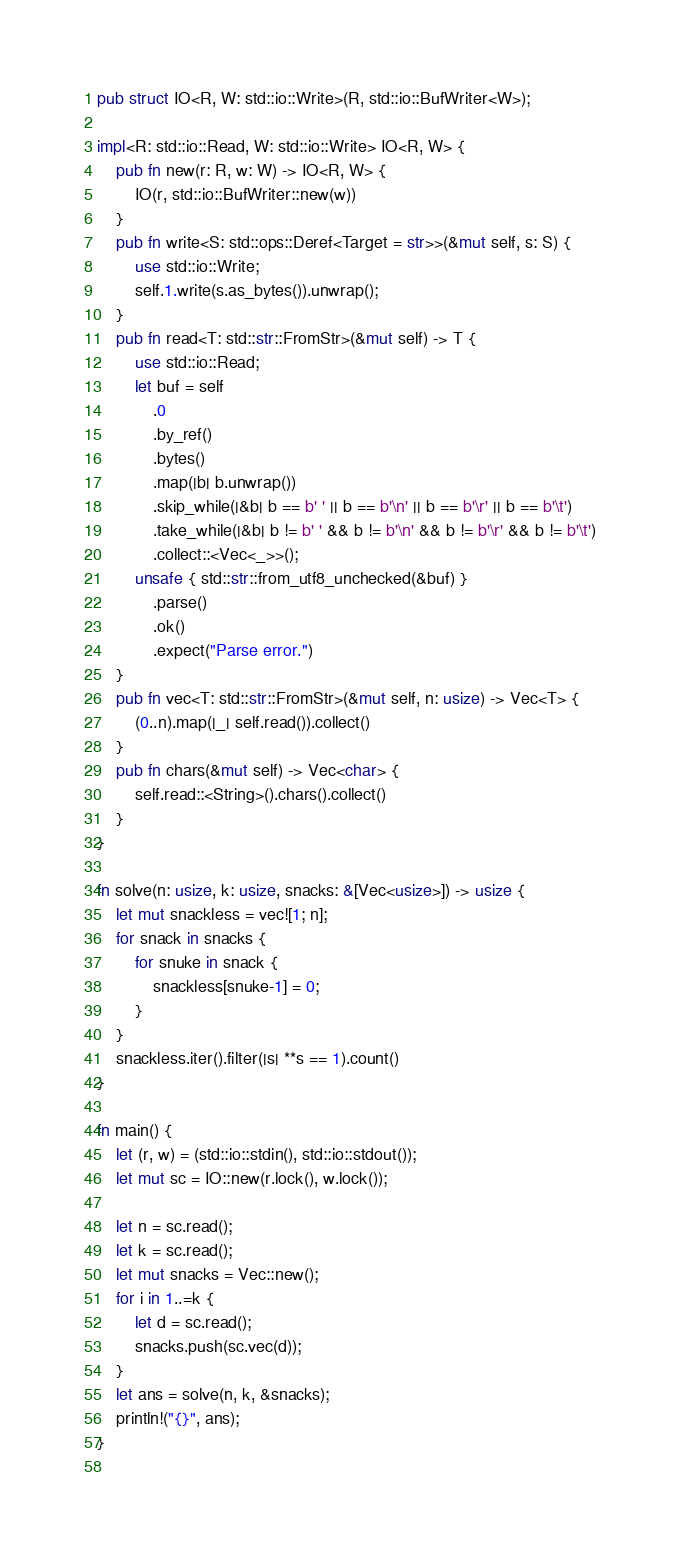Convert code to text. <code><loc_0><loc_0><loc_500><loc_500><_Rust_>pub struct IO<R, W: std::io::Write>(R, std::io::BufWriter<W>);
 
impl<R: std::io::Read, W: std::io::Write> IO<R, W> {
    pub fn new(r: R, w: W) -> IO<R, W> {
        IO(r, std::io::BufWriter::new(w))
    }
    pub fn write<S: std::ops::Deref<Target = str>>(&mut self, s: S) {
        use std::io::Write;
        self.1.write(s.as_bytes()).unwrap();
    }
    pub fn read<T: std::str::FromStr>(&mut self) -> T {
        use std::io::Read;
        let buf = self
            .0
            .by_ref()
            .bytes()
            .map(|b| b.unwrap())
            .skip_while(|&b| b == b' ' || b == b'\n' || b == b'\r' || b == b'\t')
            .take_while(|&b| b != b' ' && b != b'\n' && b != b'\r' && b != b'\t')
            .collect::<Vec<_>>();
        unsafe { std::str::from_utf8_unchecked(&buf) }
            .parse()
            .ok()
            .expect("Parse error.")
    }
    pub fn vec<T: std::str::FromStr>(&mut self, n: usize) -> Vec<T> {
        (0..n).map(|_| self.read()).collect()
    }
    pub fn chars(&mut self) -> Vec<char> {
        self.read::<String>().chars().collect()
    }
}

fn solve(n: usize, k: usize, snacks: &[Vec<usize>]) -> usize {
    let mut snackless = vec![1; n];
    for snack in snacks {
        for snuke in snack {
            snackless[snuke-1] = 0;
        }
    }
    snackless.iter().filter(|s| **s == 1).count()
}

fn main() {
    let (r, w) = (std::io::stdin(), std::io::stdout());
    let mut sc = IO::new(r.lock(), w.lock());

    let n = sc.read();
    let k = sc.read();
    let mut snacks = Vec::new();
    for i in 1..=k {
        let d = sc.read();
        snacks.push(sc.vec(d));
    }
    let ans = solve(n, k, &snacks);
    println!("{}", ans);
}
 
</code> 